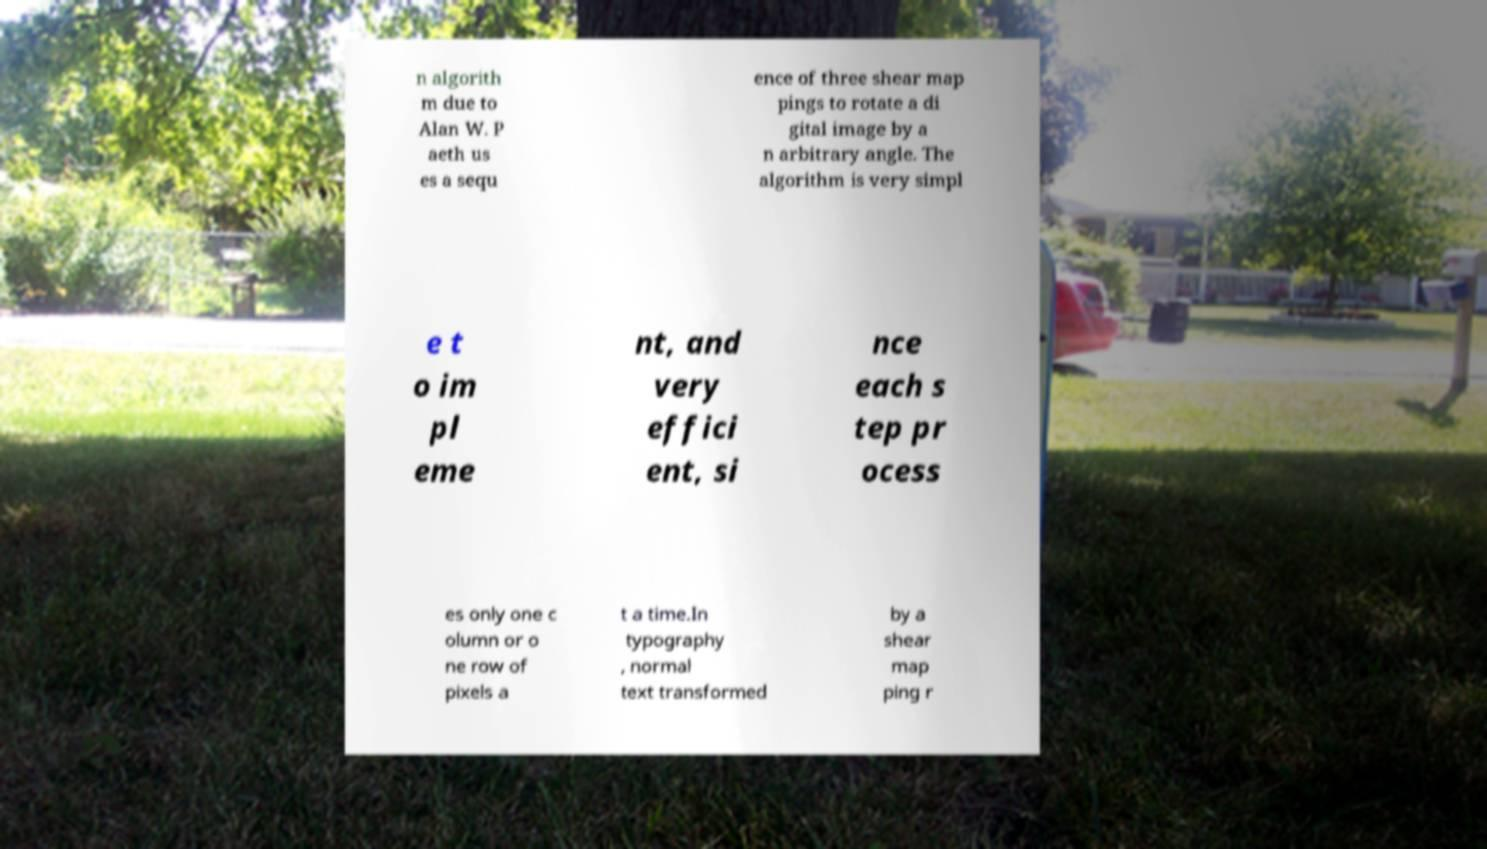Could you extract and type out the text from this image? n algorith m due to Alan W. P aeth us es a sequ ence of three shear map pings to rotate a di gital image by a n arbitrary angle. The algorithm is very simpl e t o im pl eme nt, and very effici ent, si nce each s tep pr ocess es only one c olumn or o ne row of pixels a t a time.In typography , normal text transformed by a shear map ping r 